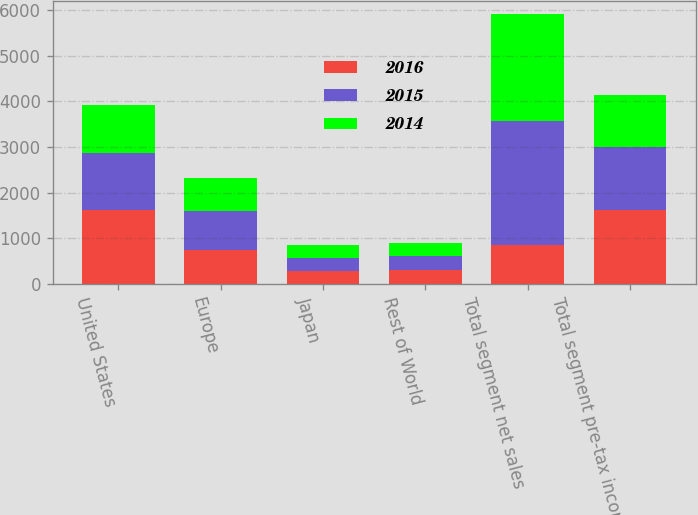<chart> <loc_0><loc_0><loc_500><loc_500><stacked_bar_chart><ecel><fcel>United States<fcel>Europe<fcel>Japan<fcel>Rest of World<fcel>Total segment net sales<fcel>Total segment pre-tax income<nl><fcel>2016<fcel>1615.7<fcel>745.9<fcel>279.6<fcel>303.6<fcel>842.9<fcel>1623.7<nl><fcel>2015<fcel>1262.8<fcel>842.9<fcel>297.2<fcel>315.1<fcel>2718<fcel>1378.5<nl><fcel>2014<fcel>1047.3<fcel>741.4<fcel>270.8<fcel>285.1<fcel>2344.6<fcel>1137.5<nl></chart> 